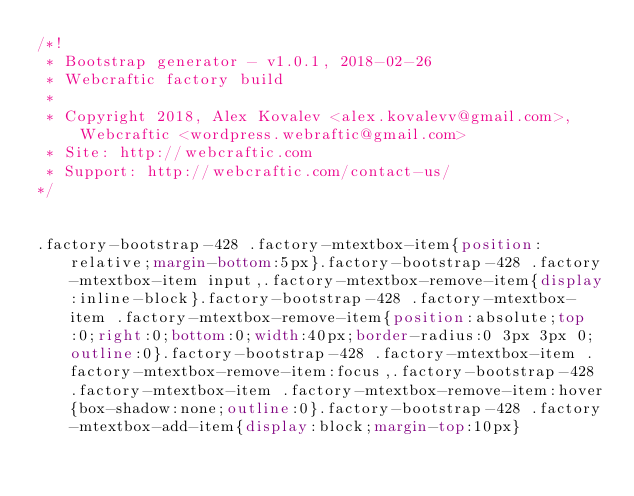Convert code to text. <code><loc_0><loc_0><loc_500><loc_500><_CSS_>/*!
 * Bootstrap generator - v1.0.1, 2018-02-26 
 * Webcraftic factory build 
 * 
 * Copyright 2018, Alex Kovalev <alex.kovalevv@gmail.com>, Webcraftic <wordpress.webraftic@gmail.com> 
 * Site: http://webcraftic.com 
 * Support: http://webcraftic.com/contact-us/ 
*/


.factory-bootstrap-428 .factory-mtextbox-item{position:relative;margin-bottom:5px}.factory-bootstrap-428 .factory-mtextbox-item input,.factory-mtextbox-remove-item{display:inline-block}.factory-bootstrap-428 .factory-mtextbox-item .factory-mtextbox-remove-item{position:absolute;top:0;right:0;bottom:0;width:40px;border-radius:0 3px 3px 0;outline:0}.factory-bootstrap-428 .factory-mtextbox-item .factory-mtextbox-remove-item:focus,.factory-bootstrap-428 .factory-mtextbox-item .factory-mtextbox-remove-item:hover{box-shadow:none;outline:0}.factory-bootstrap-428 .factory-mtextbox-add-item{display:block;margin-top:10px}</code> 